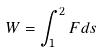Convert formula to latex. <formula><loc_0><loc_0><loc_500><loc_500>W = \int _ { 1 } ^ { 2 } F d s</formula> 